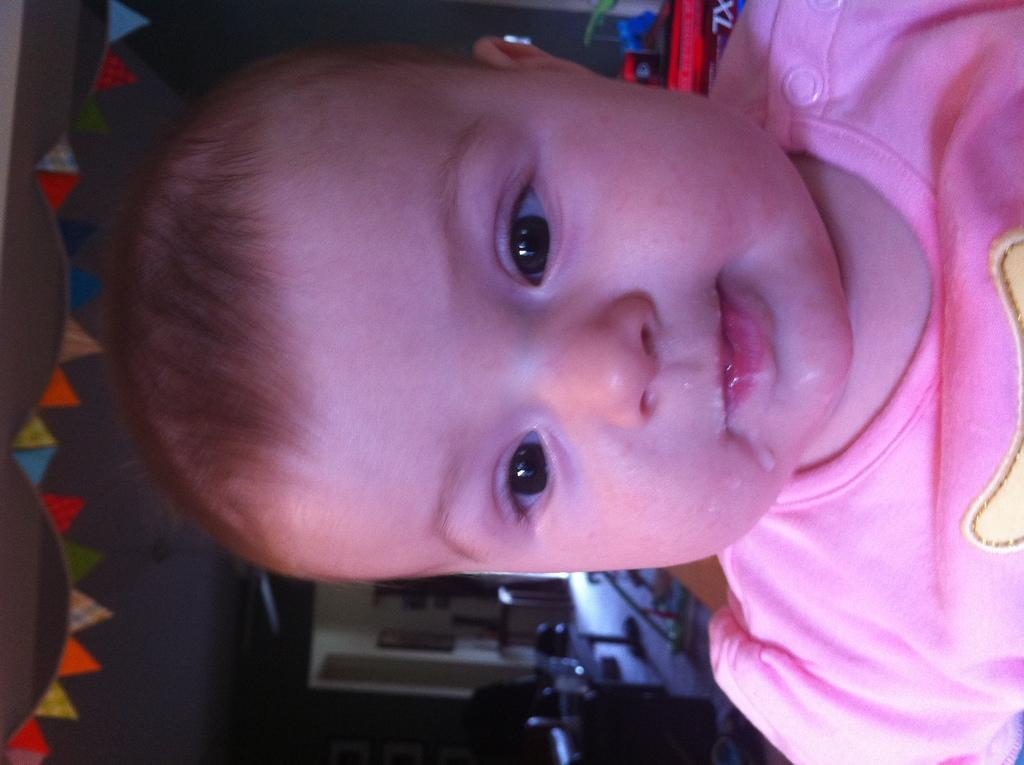What is the main subject in the foreground of the image? There is a baby in the foreground of the image. What is the baby wearing? The baby is wearing a pink T-shirt. What decorative objects can be seen on the left side of the image? There are bunting flags on the left side of the image. Can you describe the background of the image? The background objects are not clear, so it is difficult to provide a detailed description. Is there a person wearing a hat in the image? There is no person wearing a hat in the image; the main subject is a baby wearing a pink T-shirt. 